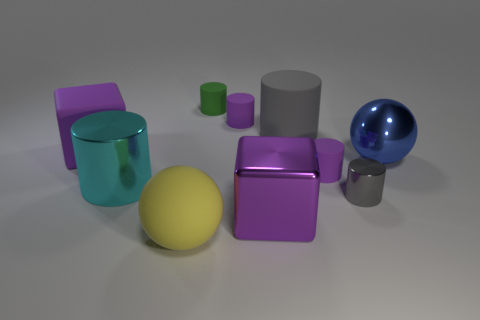There is a large cylinder that is the same color as the tiny shiny thing; what material is it?
Ensure brevity in your answer.  Rubber. How many cylinders are the same color as the large shiny block?
Your response must be concise. 2. Are there more purple rubber cubes right of the green object than big metal blocks?
Your answer should be very brief. No. How many other objects are the same shape as the cyan metallic object?
Provide a succinct answer. 5. The thing that is both in front of the cyan cylinder and right of the big gray rubber thing is made of what material?
Keep it short and to the point. Metal. What number of objects are big yellow matte objects or tiny yellow matte blocks?
Your response must be concise. 1. Are there more small purple matte things than big blue matte objects?
Your answer should be compact. Yes. There is a purple block that is on the left side of the large purple metal thing that is on the left side of the big gray object; how big is it?
Keep it short and to the point. Large. There is a big rubber thing that is the same shape as the large cyan metallic thing; what color is it?
Provide a short and direct response. Gray. The yellow thing has what size?
Keep it short and to the point. Large. 